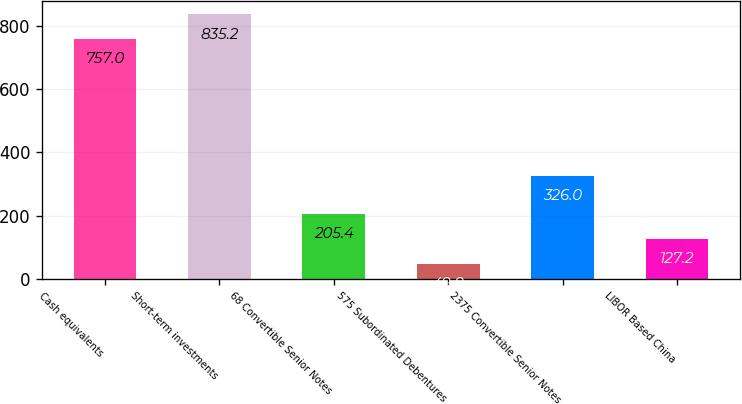Convert chart to OTSL. <chart><loc_0><loc_0><loc_500><loc_500><bar_chart><fcel>Cash equivalents<fcel>Short-term investments<fcel>68 Convertible Senior Notes<fcel>575 Subordinated Debentures<fcel>2375 Convertible Senior Notes<fcel>LIBOR Based China<nl><fcel>757<fcel>835.2<fcel>205.4<fcel>49<fcel>326<fcel>127.2<nl></chart> 